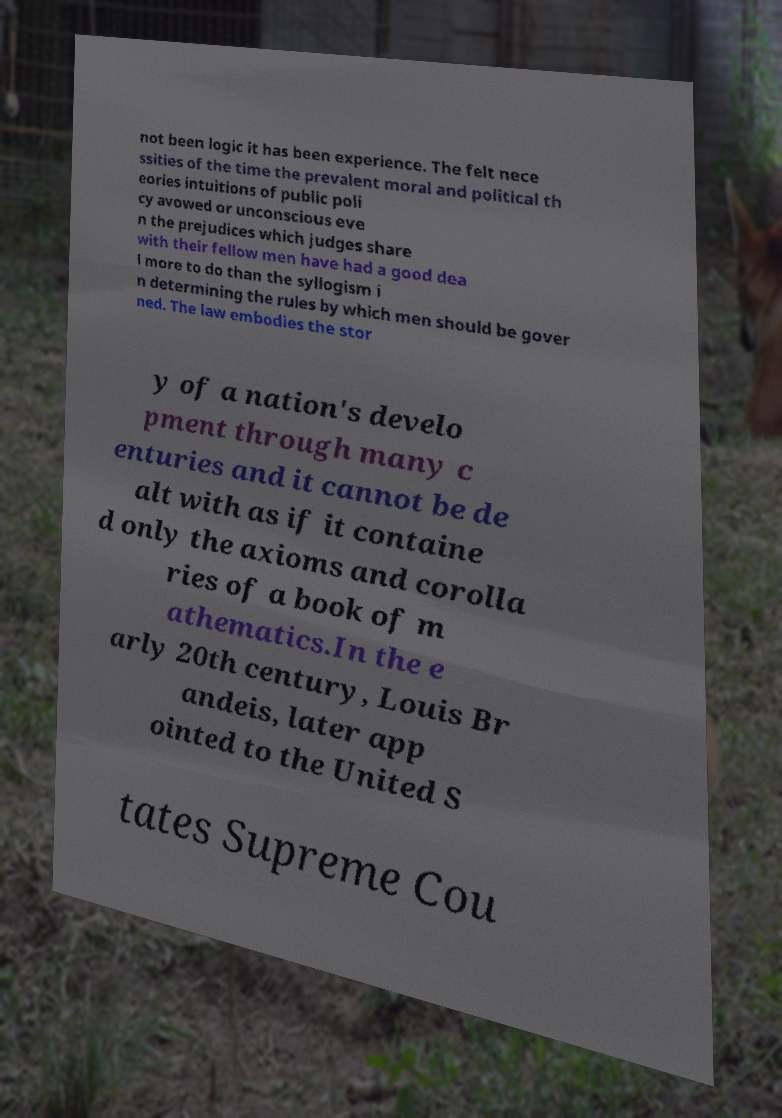Could you assist in decoding the text presented in this image and type it out clearly? not been logic it has been experience. The felt nece ssities of the time the prevalent moral and political th eories intuitions of public poli cy avowed or unconscious eve n the prejudices which judges share with their fellow men have had a good dea l more to do than the syllogism i n determining the rules by which men should be gover ned. The law embodies the stor y of a nation's develo pment through many c enturies and it cannot be de alt with as if it containe d only the axioms and corolla ries of a book of m athematics.In the e arly 20th century, Louis Br andeis, later app ointed to the United S tates Supreme Cou 